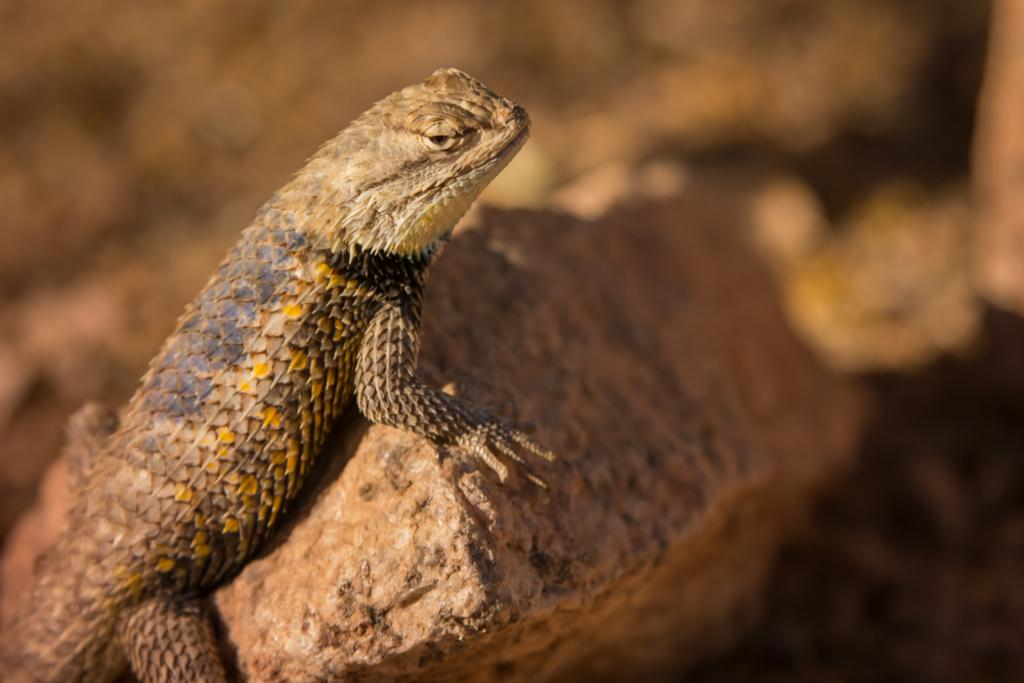What type of animal is in the image? There is a reptile in the image. What is the reptile resting on? The reptile is on a stone. Can you describe the background of the image? The background of the image is blurry. Is there a lamp illuminating the reptile in the image? There is no lamp present in the image. Can you see any water in the image? There is no water visible in the image. 